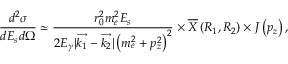Convert formula to latex. <formula><loc_0><loc_0><loc_500><loc_500>\frac { d ^ { 2 } \sigma } { d E _ { s } d \Omega } \simeq \frac { r _ { 0 } ^ { 2 } m _ { e } ^ { 2 } E _ { s } } { 2 E _ { \gamma } | \overrightarrow { k _ { 1 } } - \overrightarrow { k _ { 2 } } | \left ( m _ { e } ^ { 2 } + p _ { z } ^ { 2 } \right ) ^ { 2 } } \times \overline { X } \left ( R _ { 1 } , R _ { 2 } \right ) \times J \left ( p _ { z } \right ) ,</formula> 